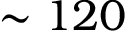<formula> <loc_0><loc_0><loc_500><loc_500>\sim 1 2 0</formula> 